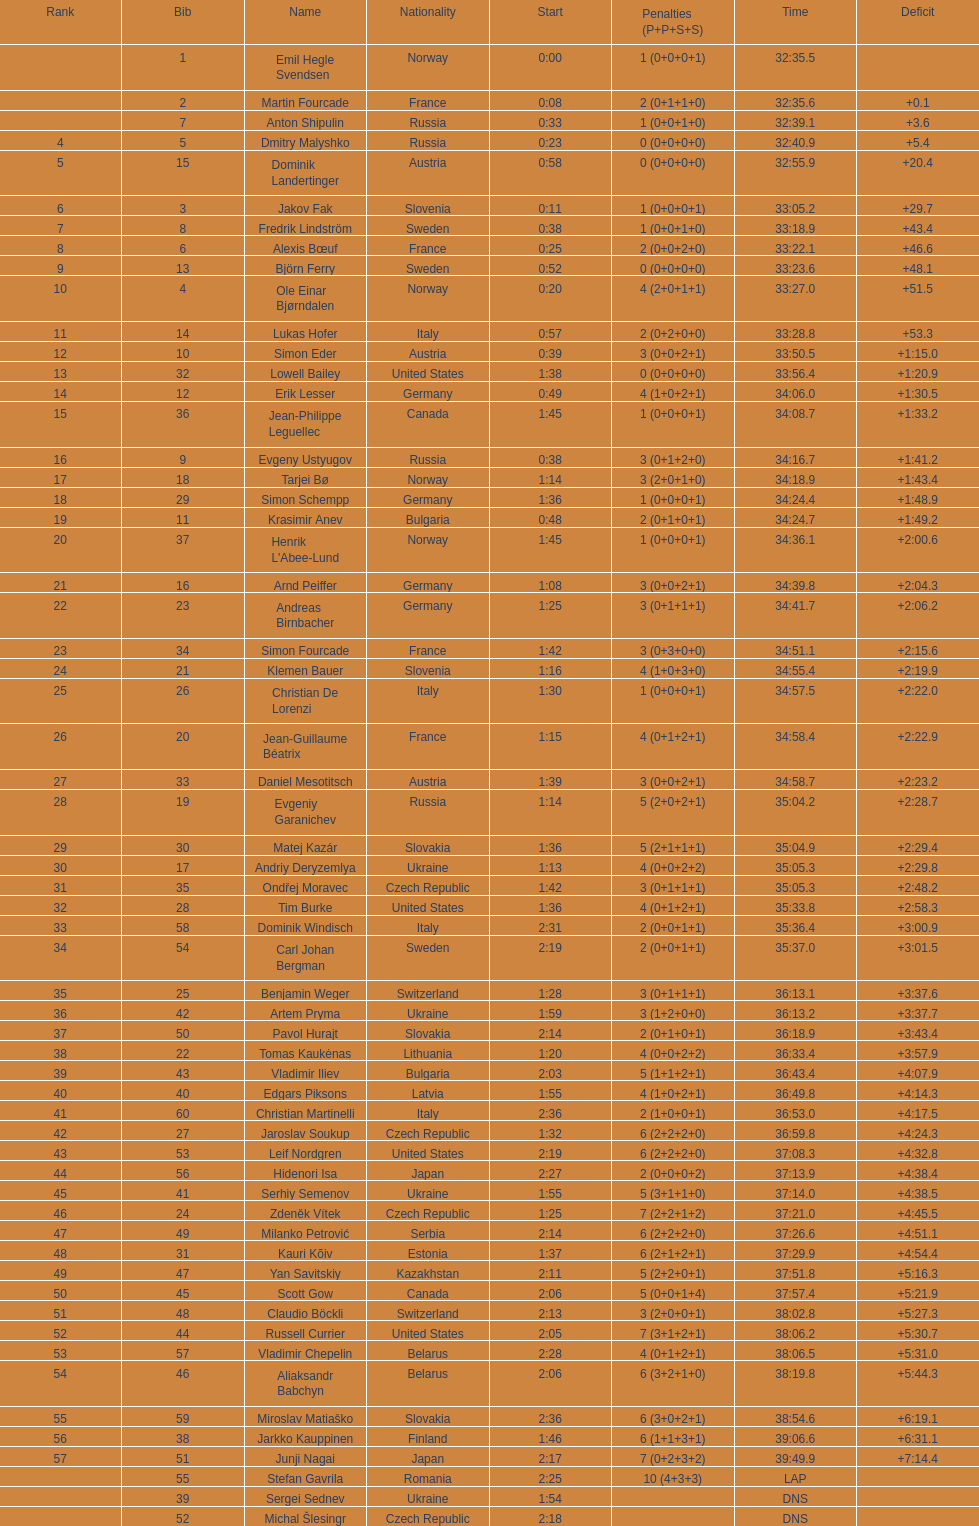How many united states participants failed to secure medals? 4. 